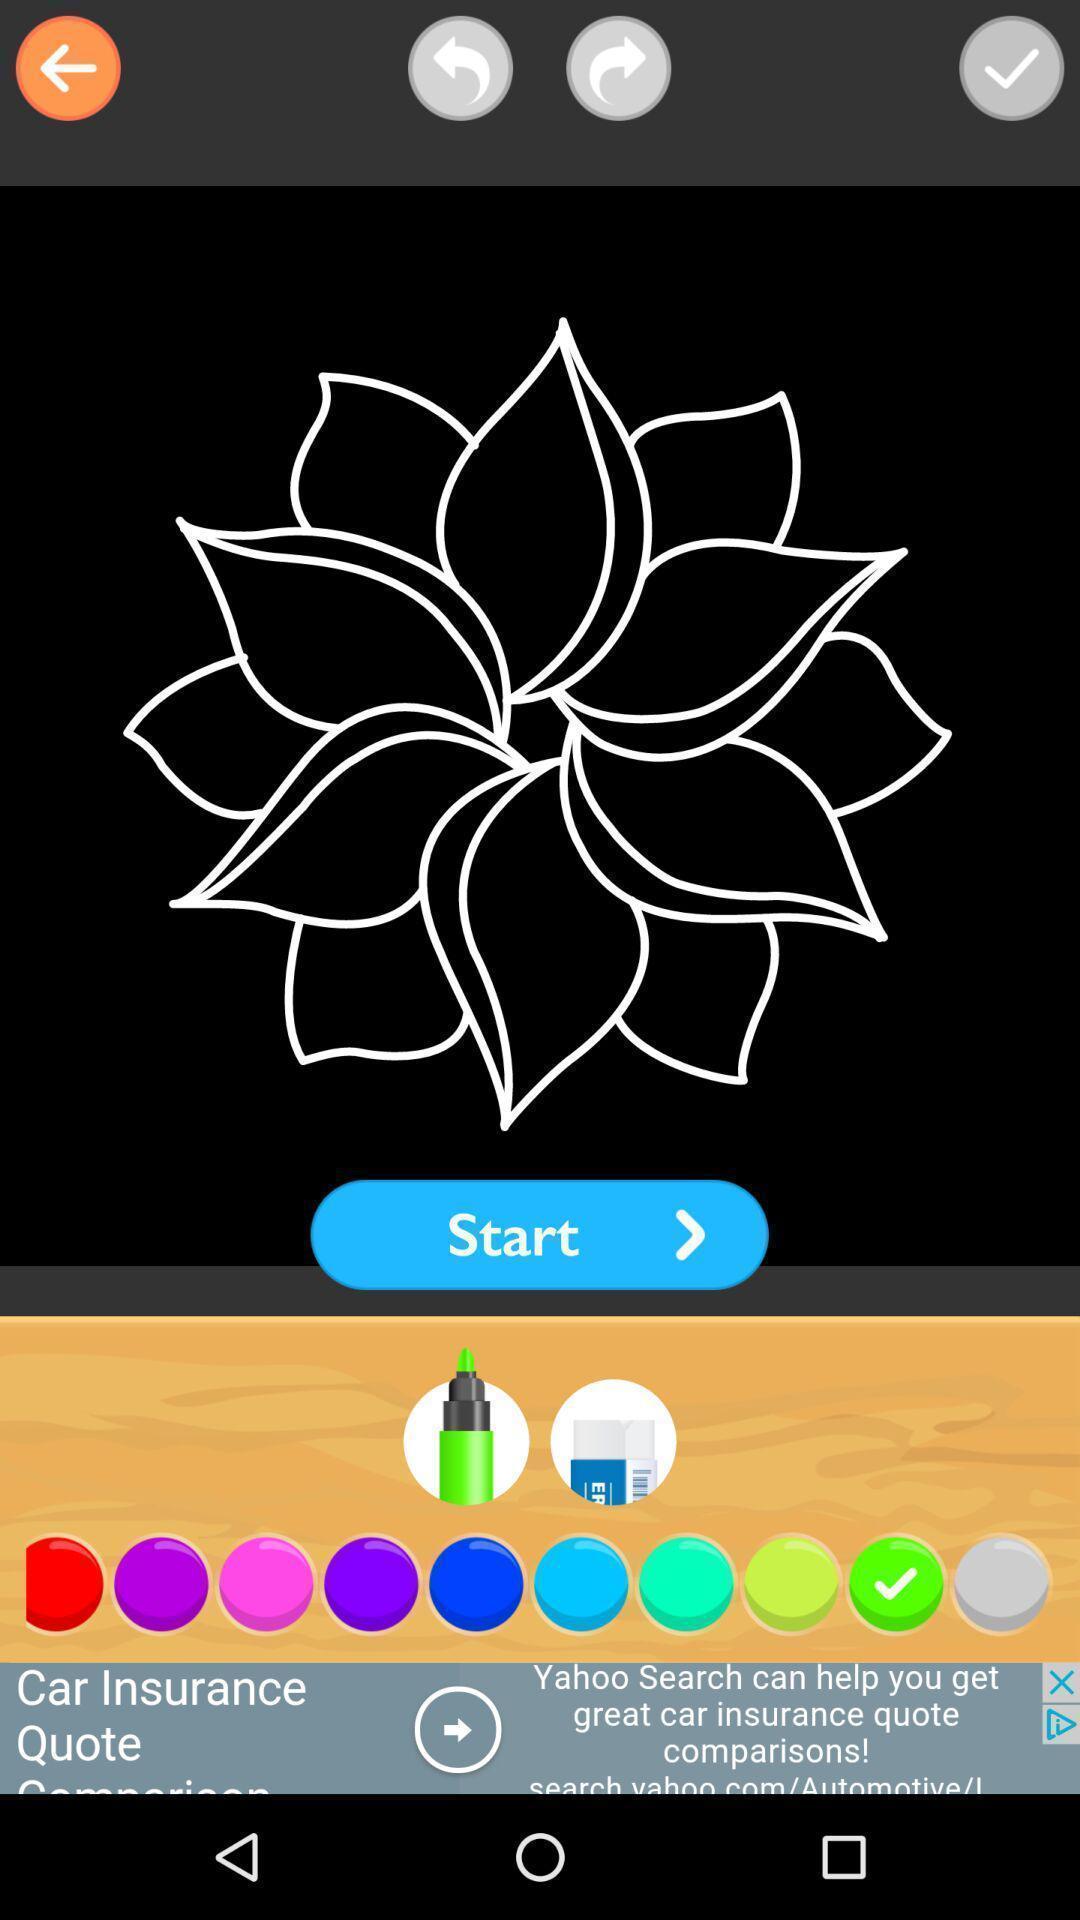Explain what's happening in this screen capture. Starting page for the art drawing app. 